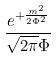Convert formula to latex. <formula><loc_0><loc_0><loc_500><loc_500>\frac { e ^ { + \frac { m ^ { 2 } } { 2 \Phi ^ { 2 } } } } { \sqrt { 2 \pi } \Phi }</formula> 